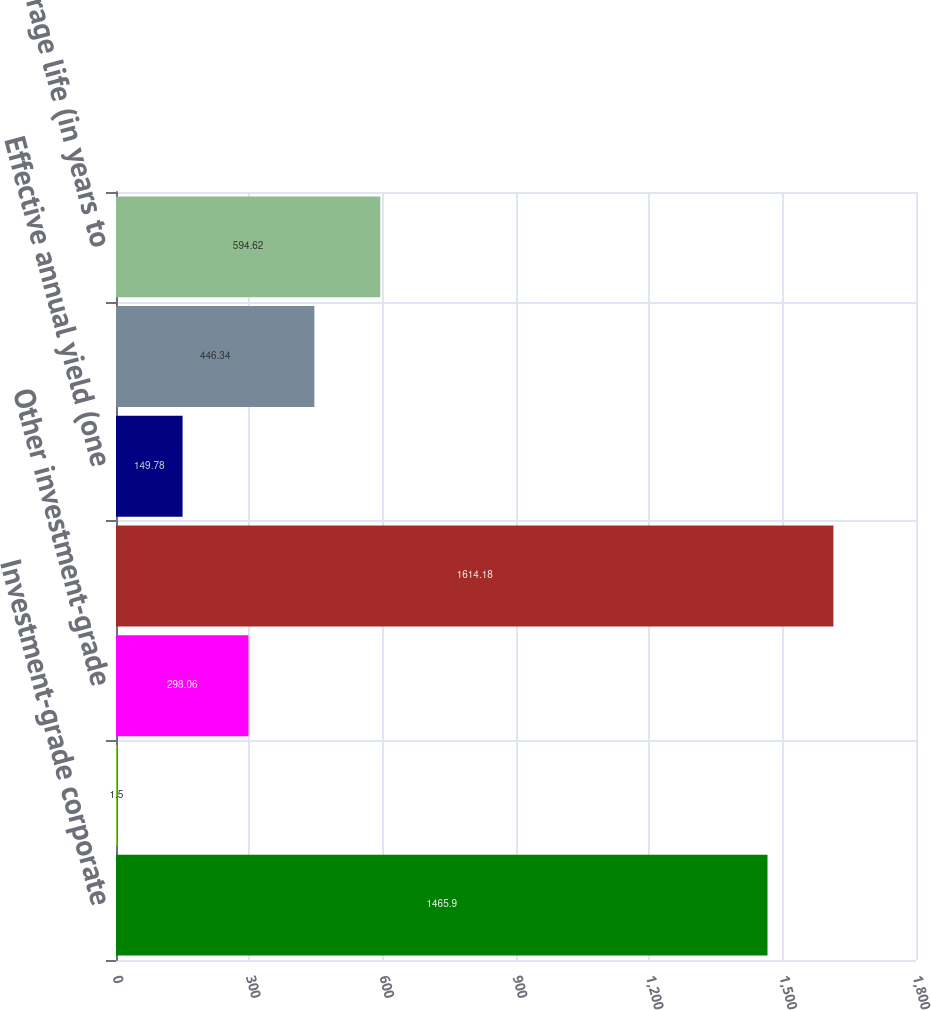Convert chart to OTSL. <chart><loc_0><loc_0><loc_500><loc_500><bar_chart><fcel>Investment-grade corporate<fcel>Taxable municipal securities<fcel>Other investment-grade<fcel>Total fixed-maturity<fcel>Effective annual yield (one<fcel>Average life (in years to next<fcel>Average life (in years to<nl><fcel>1465.9<fcel>1.5<fcel>298.06<fcel>1614.18<fcel>149.78<fcel>446.34<fcel>594.62<nl></chart> 